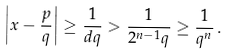Convert formula to latex. <formula><loc_0><loc_0><loc_500><loc_500>\left | x - { \frac { p } { q } } \right | \geq { \frac { 1 } { d q } } > { \frac { 1 } { 2 ^ { n - 1 } q } } \geq { \frac { 1 } { q ^ { n } } } \, .</formula> 